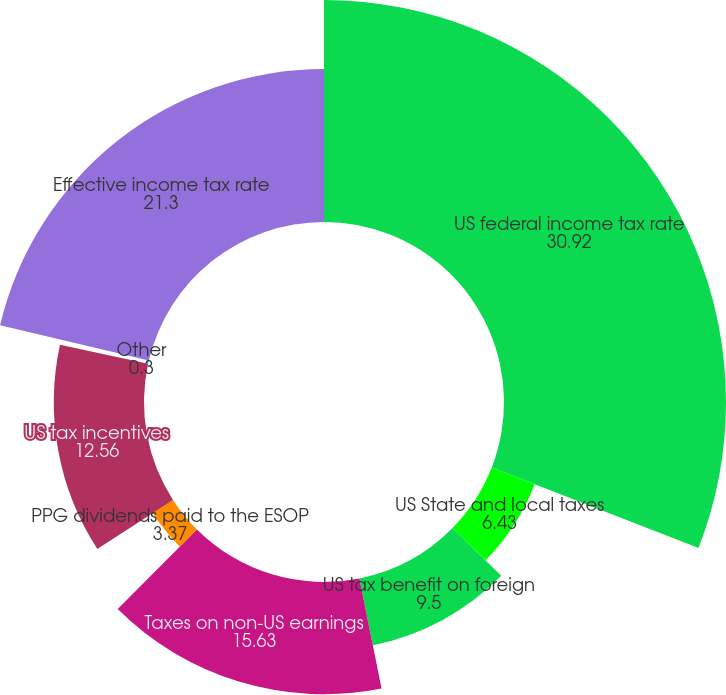Convert chart to OTSL. <chart><loc_0><loc_0><loc_500><loc_500><pie_chart><fcel>US federal income tax rate<fcel>US State and local taxes<fcel>US tax benefit on foreign<fcel>Taxes on non-US earnings<fcel>PPG dividends paid to the ESOP<fcel>US tax incentives<fcel>Other<fcel>Effective income tax rate<nl><fcel>30.92%<fcel>6.43%<fcel>9.5%<fcel>15.63%<fcel>3.37%<fcel>12.56%<fcel>0.3%<fcel>21.3%<nl></chart> 